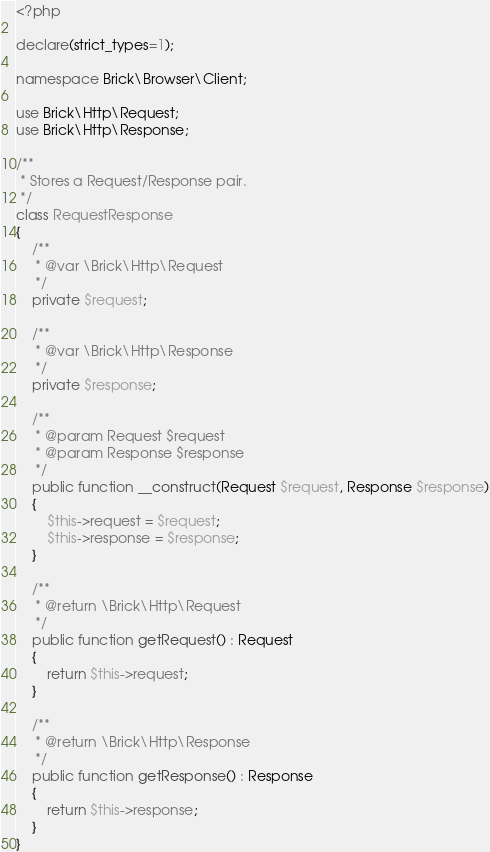Convert code to text. <code><loc_0><loc_0><loc_500><loc_500><_PHP_><?php

declare(strict_types=1);

namespace Brick\Browser\Client;

use Brick\Http\Request;
use Brick\Http\Response;

/**
 * Stores a Request/Response pair.
 */
class RequestResponse
{
    /**
     * @var \Brick\Http\Request
     */
    private $request;

    /**
     * @var \Brick\Http\Response
     */
    private $response;

    /**
     * @param Request $request
     * @param Response $response
     */
    public function __construct(Request $request, Response $response)
    {
        $this->request = $request;
        $this->response = $response;
    }

    /**
     * @return \Brick\Http\Request
     */
    public function getRequest() : Request
    {
        return $this->request;
    }

    /**
     * @return \Brick\Http\Response
     */
    public function getResponse() : Response
    {
        return $this->response;
    }
}
</code> 